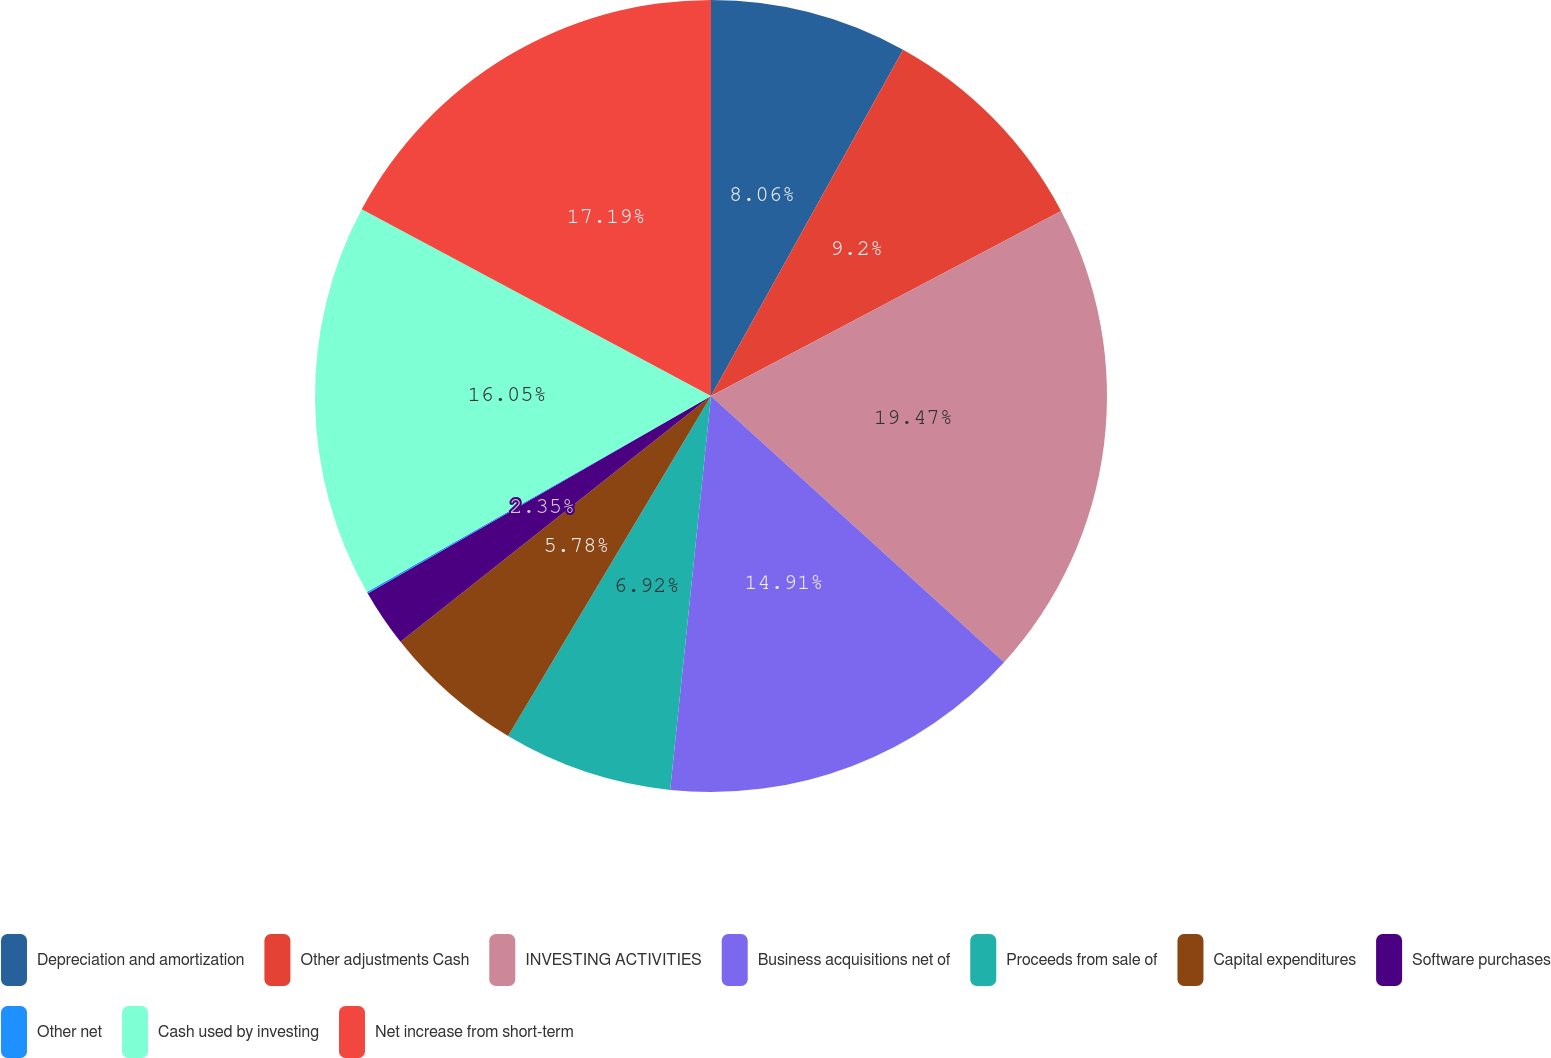Convert chart to OTSL. <chart><loc_0><loc_0><loc_500><loc_500><pie_chart><fcel>Depreciation and amortization<fcel>Other adjustments Cash<fcel>INVESTING ACTIVITIES<fcel>Business acquisitions net of<fcel>Proceeds from sale of<fcel>Capital expenditures<fcel>Software purchases<fcel>Other net<fcel>Cash used by investing<fcel>Net increase from short-term<nl><fcel>8.06%<fcel>9.2%<fcel>19.48%<fcel>14.91%<fcel>6.92%<fcel>5.78%<fcel>2.35%<fcel>0.07%<fcel>16.05%<fcel>17.19%<nl></chart> 